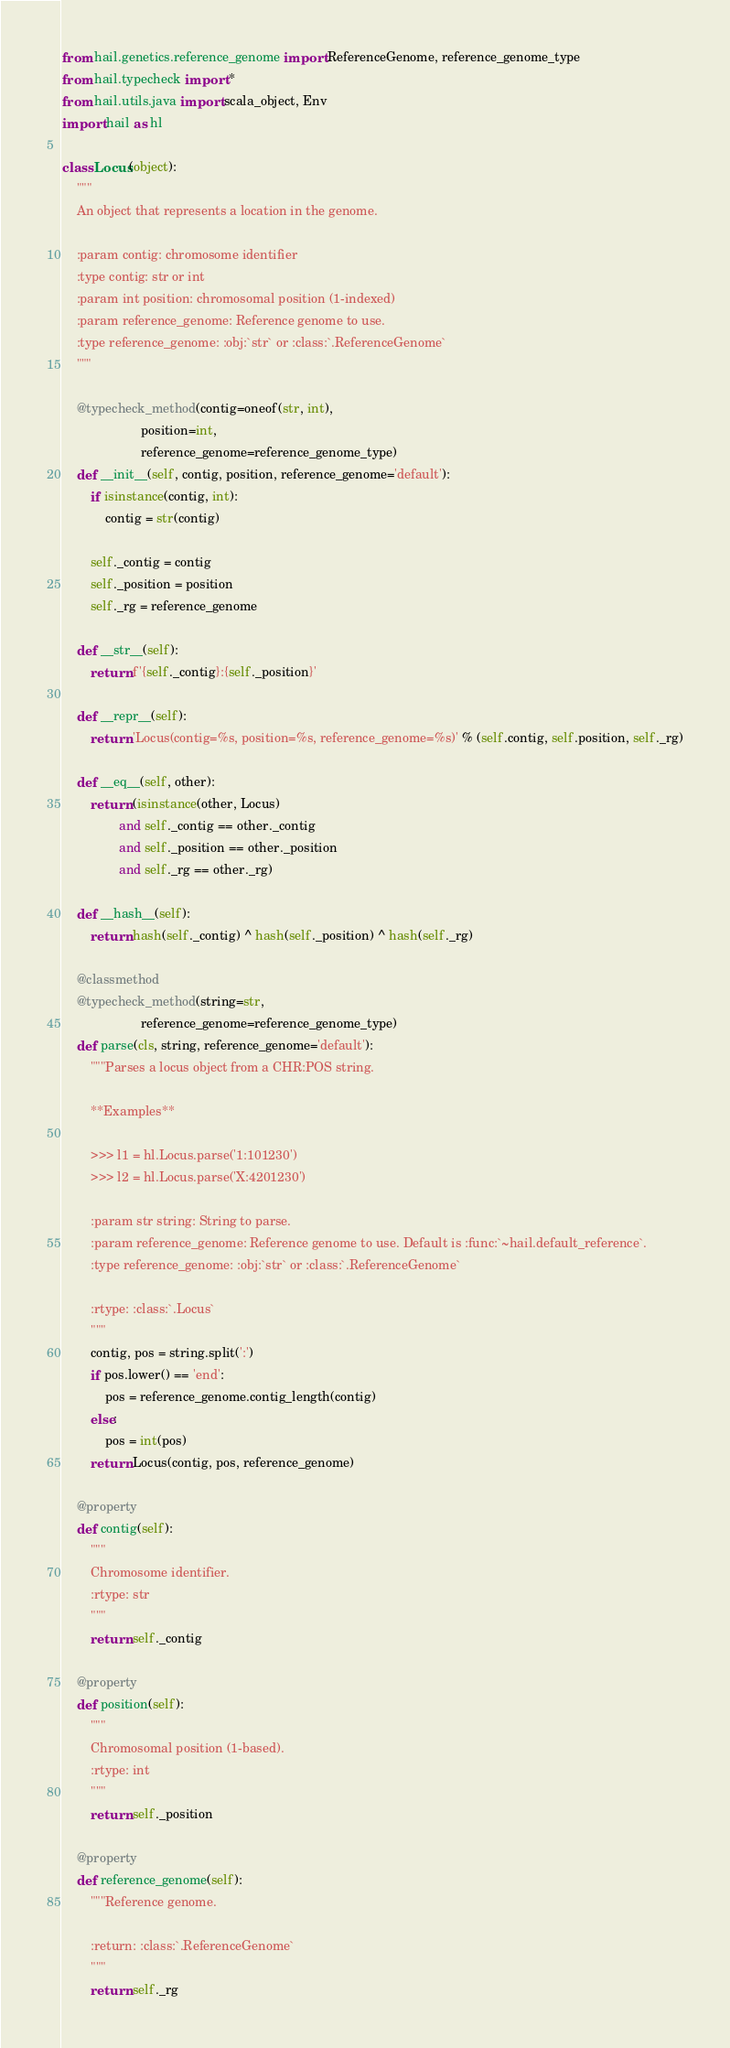Convert code to text. <code><loc_0><loc_0><loc_500><loc_500><_Python_>from hail.genetics.reference_genome import ReferenceGenome, reference_genome_type
from hail.typecheck import *
from hail.utils.java import scala_object, Env
import hail as hl

class Locus(object):
    """
    An object that represents a location in the genome.

    :param contig: chromosome identifier
    :type contig: str or int
    :param int position: chromosomal position (1-indexed)
    :param reference_genome: Reference genome to use.
    :type reference_genome: :obj:`str` or :class:`.ReferenceGenome`
    """

    @typecheck_method(contig=oneof(str, int),
                      position=int,
                      reference_genome=reference_genome_type)
    def __init__(self, contig, position, reference_genome='default'):
        if isinstance(contig, int):
            contig = str(contig)

        self._contig = contig
        self._position = position
        self._rg = reference_genome

    def __str__(self):
        return f'{self._contig}:{self._position}'

    def __repr__(self):
        return 'Locus(contig=%s, position=%s, reference_genome=%s)' % (self.contig, self.position, self._rg)

    def __eq__(self, other):
        return (isinstance(other, Locus)
                and self._contig == other._contig
                and self._position == other._position
                and self._rg == other._rg)

    def __hash__(self):
        return hash(self._contig) ^ hash(self._position) ^ hash(self._rg)

    @classmethod
    @typecheck_method(string=str,
                      reference_genome=reference_genome_type)
    def parse(cls, string, reference_genome='default'):
        """Parses a locus object from a CHR:POS string.

        **Examples**

        >>> l1 = hl.Locus.parse('1:101230')
        >>> l2 = hl.Locus.parse('X:4201230')

        :param str string: String to parse.
        :param reference_genome: Reference genome to use. Default is :func:`~hail.default_reference`.
        :type reference_genome: :obj:`str` or :class:`.ReferenceGenome`

        :rtype: :class:`.Locus`
        """
        contig, pos = string.split(':')
        if pos.lower() == 'end':
            pos = reference_genome.contig_length(contig)
        else:
            pos = int(pos)
        return Locus(contig, pos, reference_genome)

    @property
    def contig(self):
        """
        Chromosome identifier.
        :rtype: str
        """
        return self._contig

    @property
    def position(self):
        """
        Chromosomal position (1-based).
        :rtype: int
        """
        return self._position

    @property
    def reference_genome(self):
        """Reference genome.

        :return: :class:`.ReferenceGenome`
        """
        return self._rg
</code> 